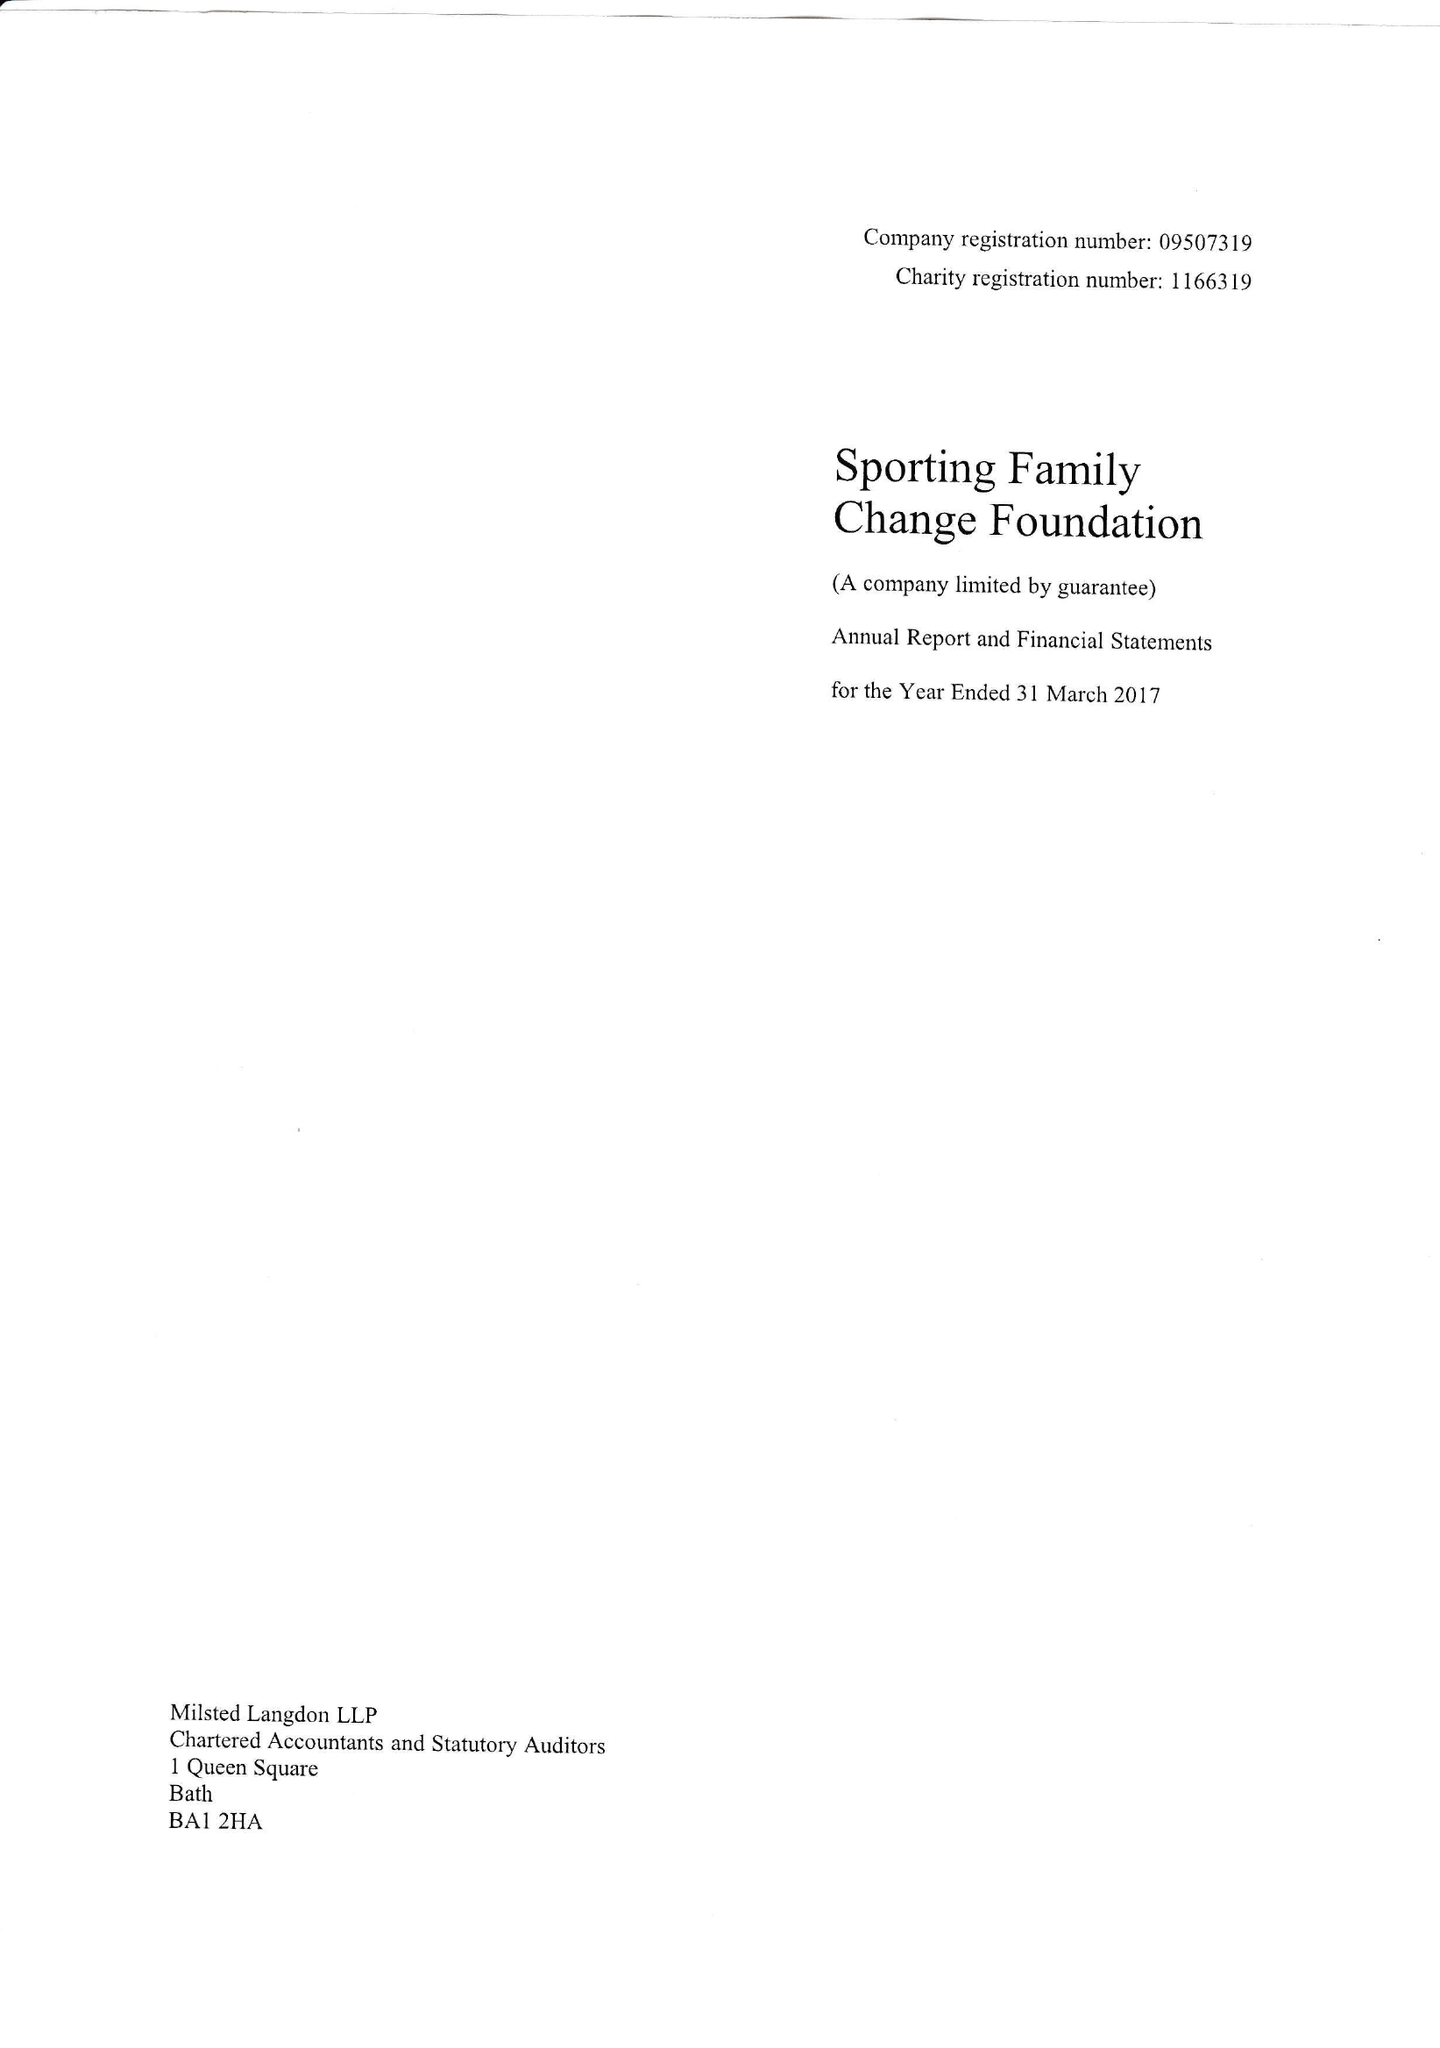What is the value for the charity_number?
Answer the question using a single word or phrase. 1166319 